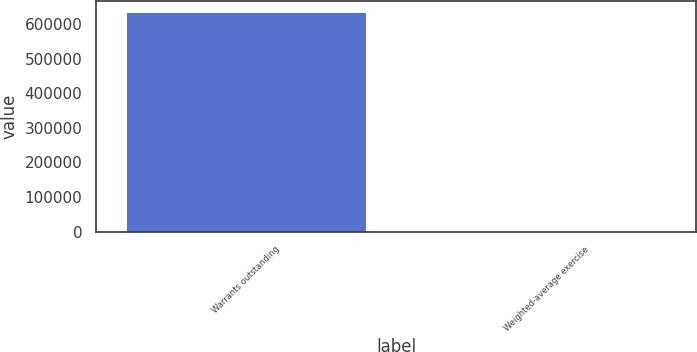Convert chart. <chart><loc_0><loc_0><loc_500><loc_500><bar_chart><fcel>Warrants outstanding<fcel>Weighted-average exercise<nl><fcel>634611<fcel>19.7<nl></chart> 